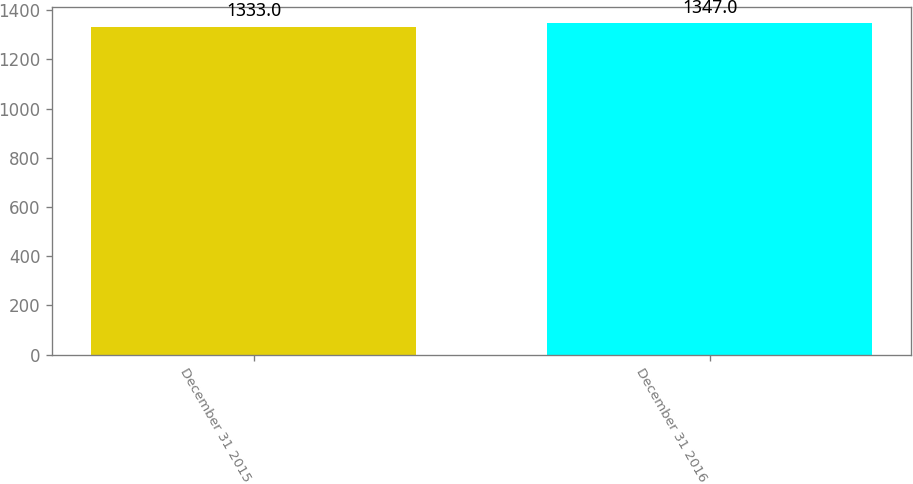Convert chart. <chart><loc_0><loc_0><loc_500><loc_500><bar_chart><fcel>December 31 2015<fcel>December 31 2016<nl><fcel>1333<fcel>1347<nl></chart> 